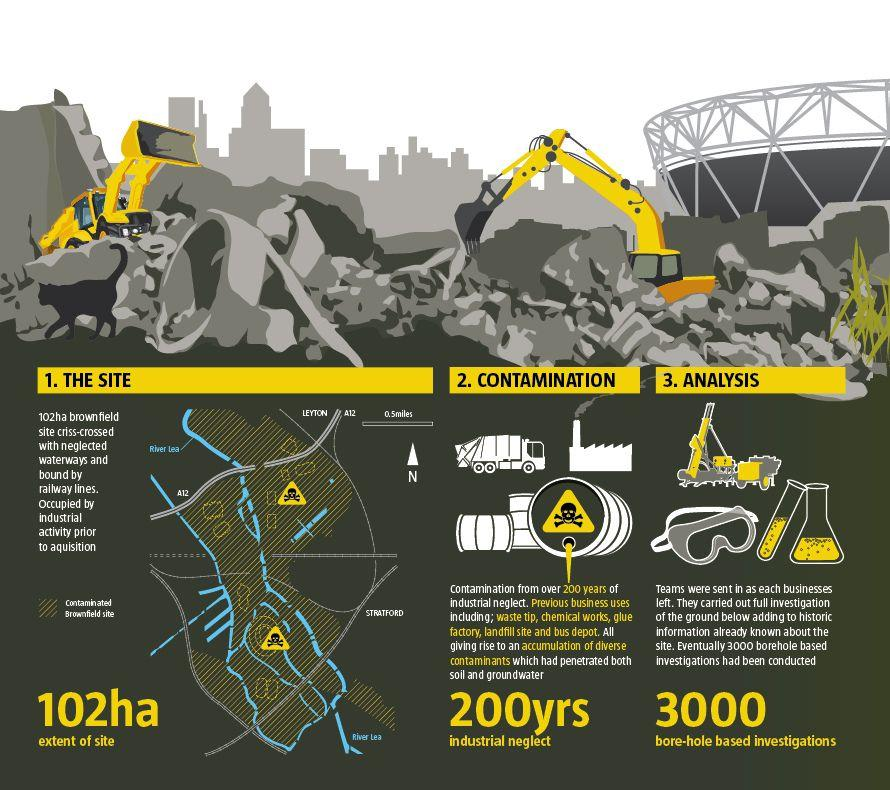Identify some key points in this picture. The site has an extent of 102 hectares. 